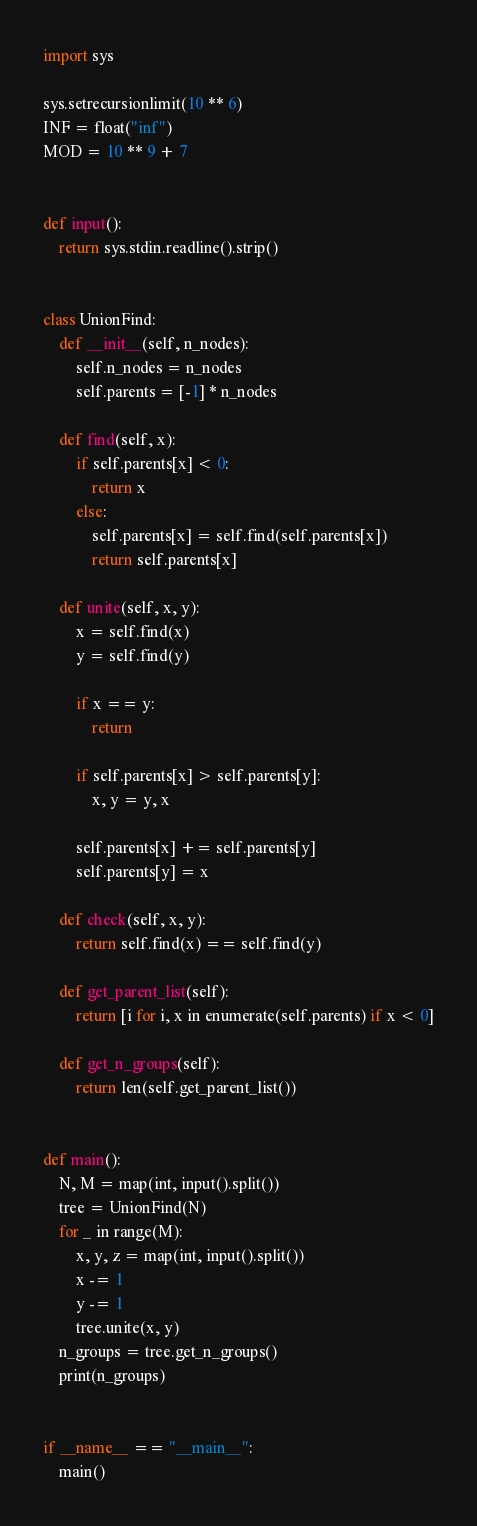<code> <loc_0><loc_0><loc_500><loc_500><_Python_>import sys

sys.setrecursionlimit(10 ** 6)
INF = float("inf")
MOD = 10 ** 9 + 7


def input():
    return sys.stdin.readline().strip()


class UnionFind:
    def __init__(self, n_nodes):
        self.n_nodes = n_nodes
        self.parents = [-1] * n_nodes

    def find(self, x):
        if self.parents[x] < 0:
            return x
        else:
            self.parents[x] = self.find(self.parents[x])
            return self.parents[x]

    def unite(self, x, y):
        x = self.find(x)
        y = self.find(y)

        if x == y:
            return

        if self.parents[x] > self.parents[y]:
            x, y = y, x

        self.parents[x] += self.parents[y]
        self.parents[y] = x

    def check(self, x, y):
        return self.find(x) == self.find(y)

    def get_parent_list(self):
        return [i for i, x in enumerate(self.parents) if x < 0]

    def get_n_groups(self):
        return len(self.get_parent_list())


def main():
    N, M = map(int, input().split())
    tree = UnionFind(N)
    for _ in range(M):
        x, y, z = map(int, input().split())
        x -= 1
        y -= 1
        tree.unite(x, y)
    n_groups = tree.get_n_groups()
    print(n_groups)


if __name__ == "__main__":
    main()
</code> 